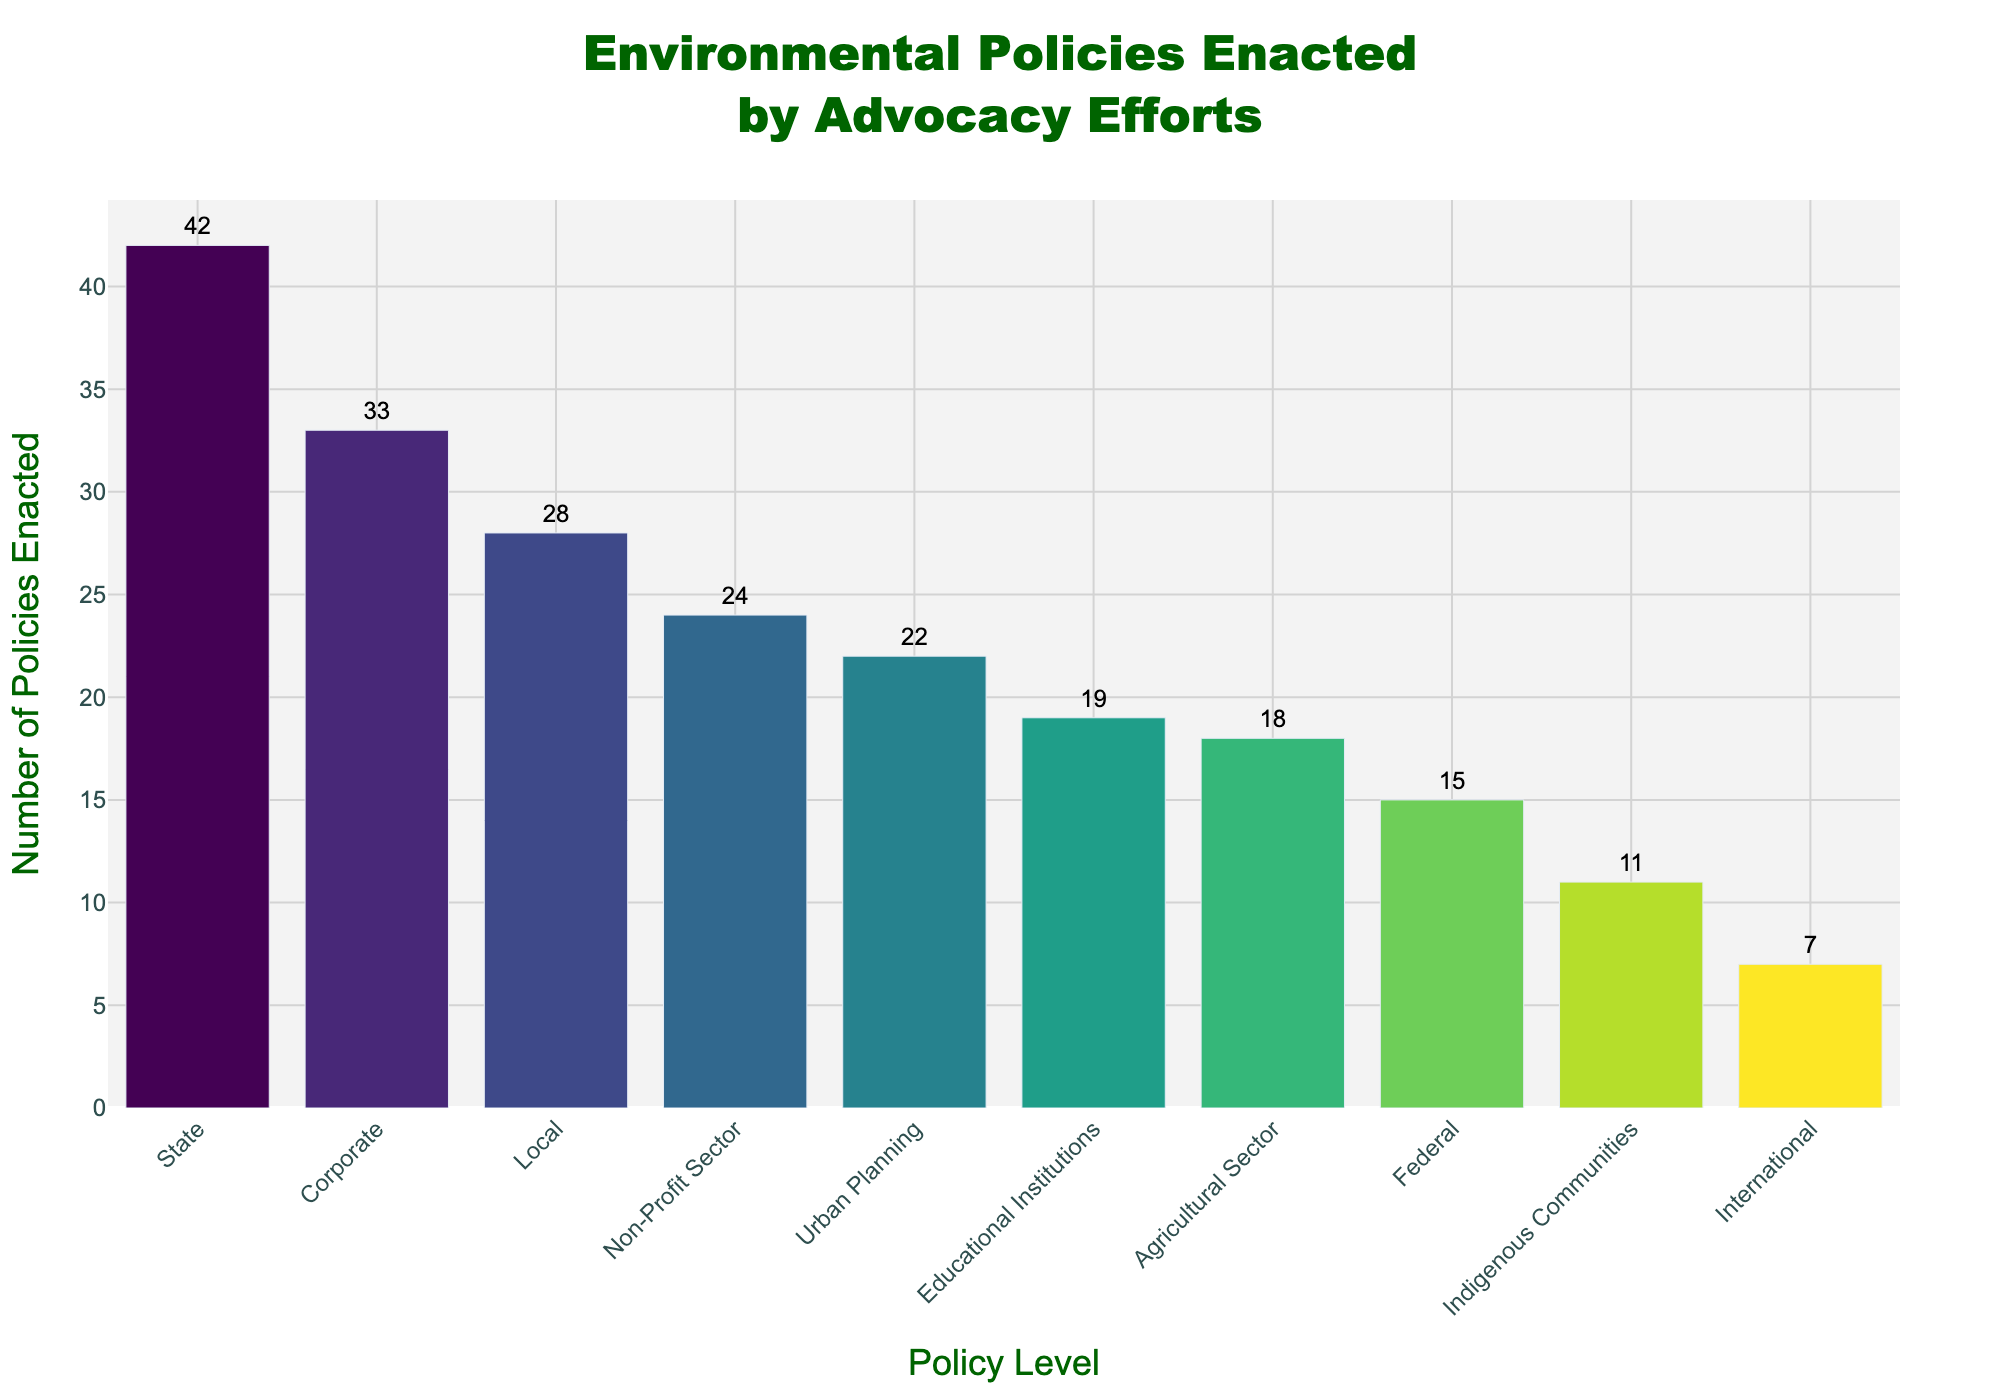Which policy level has the highest number of enacted policies? The bar representing the highest number of policies enacted reaches the topmost point on the chart. This bar is for the "State" policy level.
Answer: State Which policy level has the lowest number of enacted policies? The bar representing the lowest number of policies enacted reaches the lowest point on the chart. This bar is for the "International" policy level.
Answer: International What is the difference in the number of enacted policies between the State and Federal levels? The number of policies enacted at the State level is 42, and at the Federal level is 15. The difference is calculated as 42 - 15 = 27.
Answer: 27 How many total policies were enacted at the Local and State levels combined? The number of policies enacted at the Local level is 28, and at the State level is 42. The total is calculated as 28 + 42 = 70.
Answer: 70 What is the mean number of enacted policies across all policy levels? To find the mean, sum all the enacted policies and divide by the number of policy levels. (28 + 42 + 15 + 7 + 33 + 19 + 24 + 11 + 22 + 18) / 10 = 219 / 10 = 21.9.
Answer: 21.9 Which policy level is represented by the third tallest bar in the chart? The bars are sorted by height in descending order. The third tallest bar represents the "Corporate" policy level.
Answer: Corporate How many more policies were enacted at the Urban Planning level compared to the Indigenous Communities level? The number of policies at the Urban Planning level is 22, and at the Indigenous Communities level is 11. The difference is 22 - 11 = 11.
Answer: 11 What is the median number of policies enacted across all policy levels? To find the median, first list all policy enactments in numerical order: 7, 11, 15, 18, 19, 22, 24, 28, 33, 42. The median is the middle value, which is between 19 and 22. The median is (19 + 22) / 2 = 20.5.
Answer: 20.5 Which policy levels enacted fewer than 20 policies? By observing the chart, the policy levels with fewer than 20 policies enacted are "Federal" (15), "International" (7), "Indigenous Communities" (11), and "Agricultural Sector" (18).
Answer: Federal, International, Indigenous Communities, Agricultural Sector Which two policy levels have bars of nearly equal height and how many policies do they each have? The "Urban Planning" (22) and "Educational Institutions" (19) policy levels have bars of nearly equal height.
Answer: Urban Planning: 22, Educational Institutions: 19 